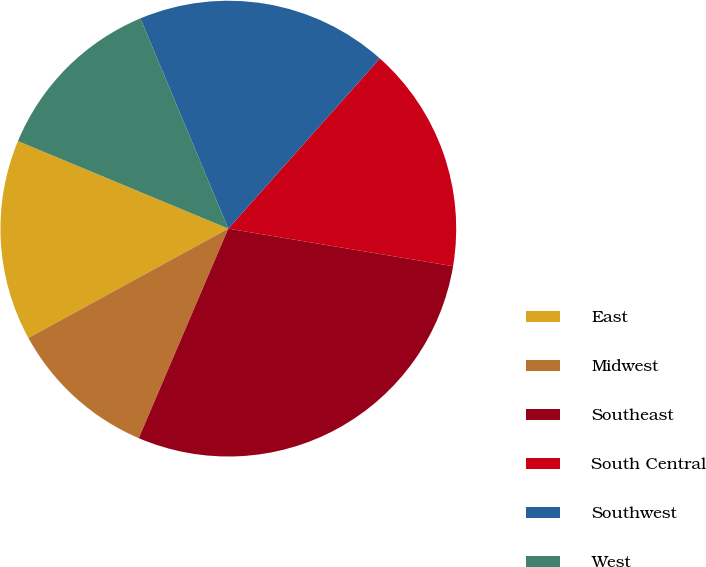Convert chart. <chart><loc_0><loc_0><loc_500><loc_500><pie_chart><fcel>East<fcel>Midwest<fcel>Southeast<fcel>South Central<fcel>Southwest<fcel>West<nl><fcel>14.24%<fcel>10.61%<fcel>28.79%<fcel>16.06%<fcel>17.88%<fcel>12.42%<nl></chart> 